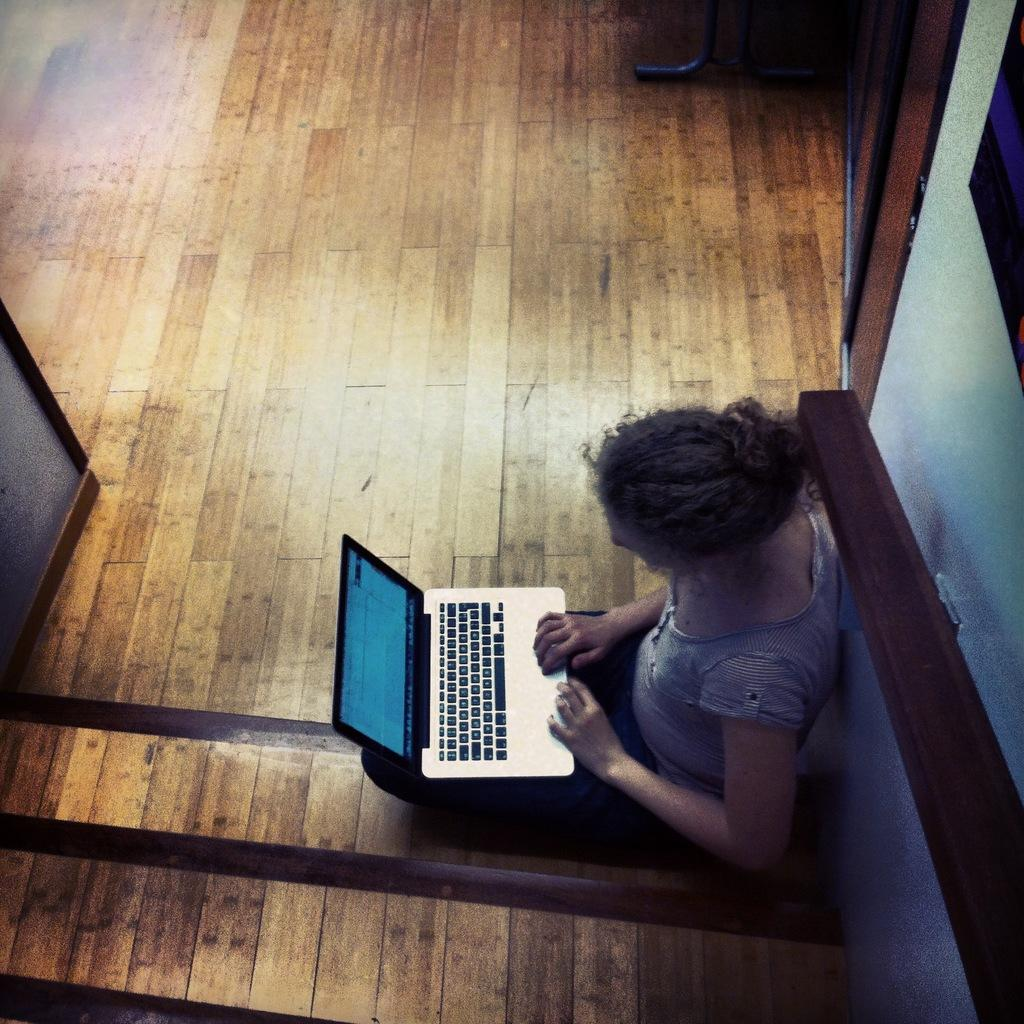Who is the main subject in the image? There is a woman in the image. What is the woman holding in the image? The woman is holding a laptop. Where is the woman sitting in the image? The woman is sitting near a wall. What type of flooring is visible in the image? There is a wooden floor in the image. What is the aftermath of the servant's actions in the image? There is no servant present in the image, and therefore no actions or aftermath to discuss. 